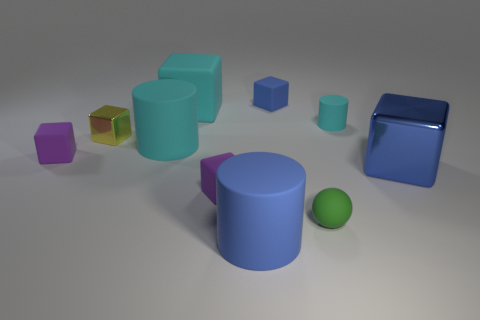How many rubber cylinders have the same color as the big shiny cube?
Your answer should be compact. 1. What material is the large blue cylinder?
Provide a short and direct response. Rubber. How many other things are there of the same size as the blue rubber cylinder?
Your response must be concise. 3. What size is the cyan cylinder right of the tiny blue rubber cube?
Ensure brevity in your answer.  Small. The big cylinder that is behind the shiny cube right of the big cylinder that is left of the big blue cylinder is made of what material?
Offer a terse response. Rubber. Is the green matte object the same shape as the blue metal object?
Provide a short and direct response. No. How many matte things are either cyan cylinders or small cyan objects?
Provide a short and direct response. 2. How many green metallic cylinders are there?
Provide a short and direct response. 0. There is a block that is the same size as the blue shiny thing; what is its color?
Your response must be concise. Cyan. Does the green thing have the same size as the cyan block?
Make the answer very short. No. 